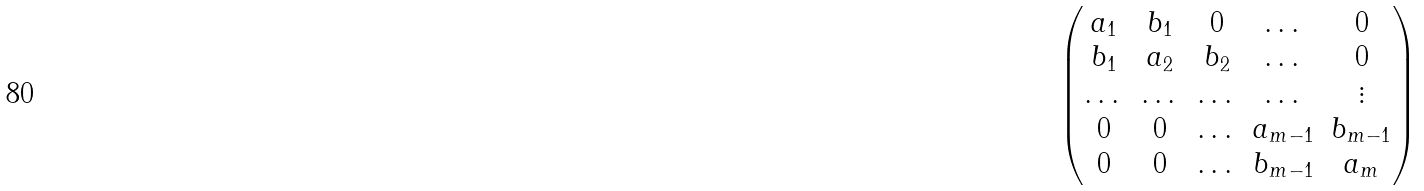Convert formula to latex. <formula><loc_0><loc_0><loc_500><loc_500>\begin{pmatrix} a _ { 1 } & b _ { 1 } & 0 & \dots & 0 \\ b _ { 1 } & a _ { 2 } & b _ { 2 } & \dots & 0 \\ \dots & \dots & \dots & \dots & \vdots \\ 0 & 0 & \dots & a _ { m - 1 } & b _ { m - 1 } \\ 0 & 0 & \dots & b _ { m - 1 } & a _ { m } \end{pmatrix}</formula> 